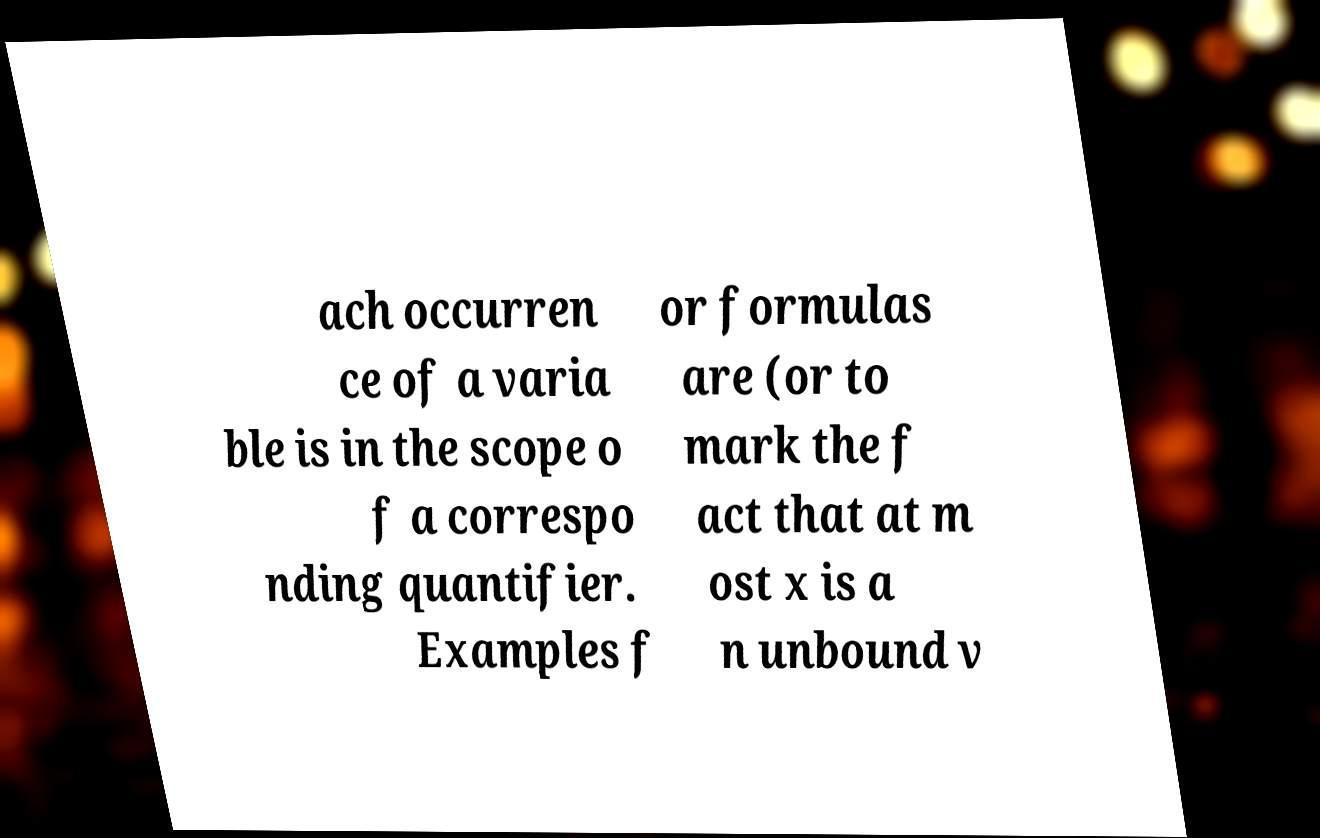Could you assist in decoding the text presented in this image and type it out clearly? ach occurren ce of a varia ble is in the scope o f a correspo nding quantifier. Examples f or formulas are (or to mark the f act that at m ost x is a n unbound v 